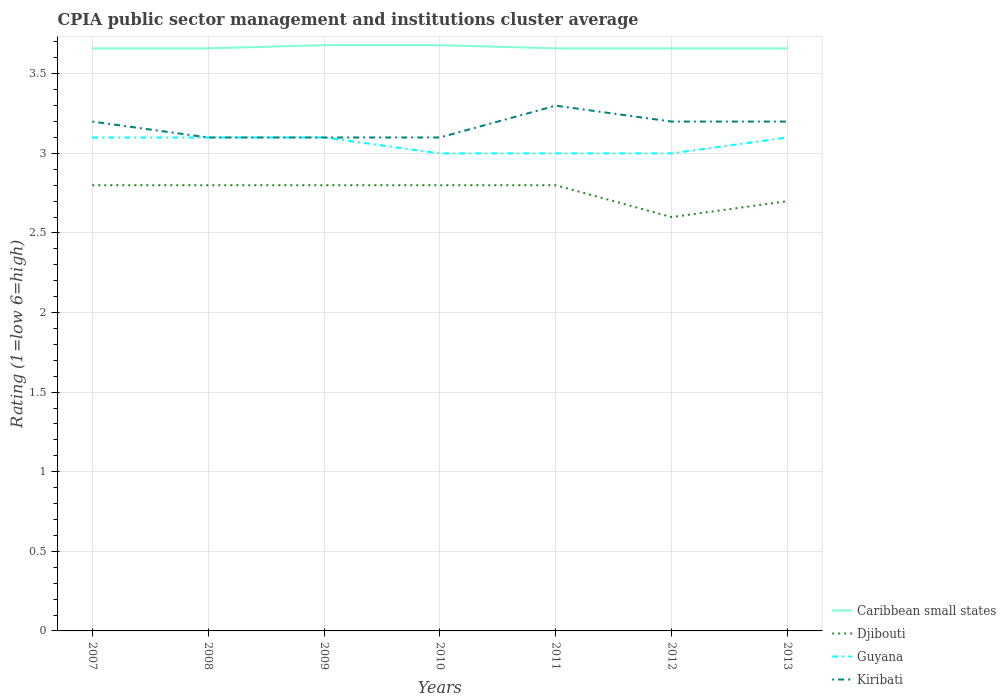How many different coloured lines are there?
Your response must be concise. 4. Does the line corresponding to Kiribati intersect with the line corresponding to Guyana?
Provide a short and direct response. Yes. Is the number of lines equal to the number of legend labels?
Ensure brevity in your answer.  Yes. Across all years, what is the maximum CPIA rating in Caribbean small states?
Provide a short and direct response. 3.66. In which year was the CPIA rating in Caribbean small states maximum?
Give a very brief answer. 2007. What is the difference between the highest and the second highest CPIA rating in Kiribati?
Your answer should be very brief. 0.2. Is the CPIA rating in Guyana strictly greater than the CPIA rating in Djibouti over the years?
Your answer should be compact. No. How many years are there in the graph?
Ensure brevity in your answer.  7. Does the graph contain grids?
Your answer should be very brief. Yes. Where does the legend appear in the graph?
Give a very brief answer. Bottom right. How are the legend labels stacked?
Give a very brief answer. Vertical. What is the title of the graph?
Your response must be concise. CPIA public sector management and institutions cluster average. Does "Tunisia" appear as one of the legend labels in the graph?
Ensure brevity in your answer.  No. What is the label or title of the X-axis?
Your answer should be compact. Years. What is the Rating (1=low 6=high) in Caribbean small states in 2007?
Provide a succinct answer. 3.66. What is the Rating (1=low 6=high) of Guyana in 2007?
Make the answer very short. 3.1. What is the Rating (1=low 6=high) of Kiribati in 2007?
Offer a very short reply. 3.2. What is the Rating (1=low 6=high) of Caribbean small states in 2008?
Ensure brevity in your answer.  3.66. What is the Rating (1=low 6=high) of Djibouti in 2008?
Your answer should be compact. 2.8. What is the Rating (1=low 6=high) of Caribbean small states in 2009?
Your answer should be compact. 3.68. What is the Rating (1=low 6=high) of Djibouti in 2009?
Your answer should be very brief. 2.8. What is the Rating (1=low 6=high) in Guyana in 2009?
Give a very brief answer. 3.1. What is the Rating (1=low 6=high) of Kiribati in 2009?
Give a very brief answer. 3.1. What is the Rating (1=low 6=high) of Caribbean small states in 2010?
Keep it short and to the point. 3.68. What is the Rating (1=low 6=high) in Kiribati in 2010?
Your response must be concise. 3.1. What is the Rating (1=low 6=high) of Caribbean small states in 2011?
Provide a short and direct response. 3.66. What is the Rating (1=low 6=high) of Guyana in 2011?
Your response must be concise. 3. What is the Rating (1=low 6=high) in Kiribati in 2011?
Your answer should be very brief. 3.3. What is the Rating (1=low 6=high) in Caribbean small states in 2012?
Make the answer very short. 3.66. What is the Rating (1=low 6=high) in Guyana in 2012?
Keep it short and to the point. 3. What is the Rating (1=low 6=high) in Kiribati in 2012?
Your response must be concise. 3.2. What is the Rating (1=low 6=high) of Caribbean small states in 2013?
Offer a very short reply. 3.66. What is the Rating (1=low 6=high) in Kiribati in 2013?
Your response must be concise. 3.2. Across all years, what is the maximum Rating (1=low 6=high) of Caribbean small states?
Your response must be concise. 3.68. Across all years, what is the maximum Rating (1=low 6=high) in Guyana?
Offer a terse response. 3.1. Across all years, what is the minimum Rating (1=low 6=high) in Caribbean small states?
Your answer should be very brief. 3.66. Across all years, what is the minimum Rating (1=low 6=high) in Djibouti?
Offer a very short reply. 2.6. Across all years, what is the minimum Rating (1=low 6=high) in Guyana?
Ensure brevity in your answer.  3. Across all years, what is the minimum Rating (1=low 6=high) of Kiribati?
Provide a short and direct response. 3.1. What is the total Rating (1=low 6=high) in Caribbean small states in the graph?
Make the answer very short. 25.66. What is the total Rating (1=low 6=high) in Djibouti in the graph?
Your response must be concise. 19.3. What is the total Rating (1=low 6=high) of Guyana in the graph?
Offer a very short reply. 21.4. What is the total Rating (1=low 6=high) of Kiribati in the graph?
Your response must be concise. 22.2. What is the difference between the Rating (1=low 6=high) of Djibouti in 2007 and that in 2008?
Provide a short and direct response. 0. What is the difference between the Rating (1=low 6=high) of Kiribati in 2007 and that in 2008?
Give a very brief answer. 0.1. What is the difference between the Rating (1=low 6=high) in Caribbean small states in 2007 and that in 2009?
Ensure brevity in your answer.  -0.02. What is the difference between the Rating (1=low 6=high) of Guyana in 2007 and that in 2009?
Offer a terse response. 0. What is the difference between the Rating (1=low 6=high) of Caribbean small states in 2007 and that in 2010?
Offer a terse response. -0.02. What is the difference between the Rating (1=low 6=high) of Caribbean small states in 2007 and that in 2012?
Your answer should be very brief. 0. What is the difference between the Rating (1=low 6=high) in Djibouti in 2007 and that in 2012?
Your answer should be very brief. 0.2. What is the difference between the Rating (1=low 6=high) of Guyana in 2007 and that in 2012?
Your answer should be compact. 0.1. What is the difference between the Rating (1=low 6=high) in Guyana in 2007 and that in 2013?
Your response must be concise. 0. What is the difference between the Rating (1=low 6=high) in Kiribati in 2007 and that in 2013?
Ensure brevity in your answer.  0. What is the difference between the Rating (1=low 6=high) of Caribbean small states in 2008 and that in 2009?
Offer a terse response. -0.02. What is the difference between the Rating (1=low 6=high) of Djibouti in 2008 and that in 2009?
Your answer should be compact. 0. What is the difference between the Rating (1=low 6=high) of Caribbean small states in 2008 and that in 2010?
Offer a very short reply. -0.02. What is the difference between the Rating (1=low 6=high) in Djibouti in 2008 and that in 2011?
Keep it short and to the point. 0. What is the difference between the Rating (1=low 6=high) of Guyana in 2008 and that in 2011?
Offer a terse response. 0.1. What is the difference between the Rating (1=low 6=high) of Caribbean small states in 2008 and that in 2012?
Your answer should be compact. 0. What is the difference between the Rating (1=low 6=high) of Djibouti in 2008 and that in 2012?
Keep it short and to the point. 0.2. What is the difference between the Rating (1=low 6=high) of Guyana in 2008 and that in 2012?
Your response must be concise. 0.1. What is the difference between the Rating (1=low 6=high) of Caribbean small states in 2008 and that in 2013?
Give a very brief answer. 0. What is the difference between the Rating (1=low 6=high) of Kiribati in 2008 and that in 2013?
Your answer should be very brief. -0.1. What is the difference between the Rating (1=low 6=high) in Caribbean small states in 2009 and that in 2010?
Your answer should be very brief. 0. What is the difference between the Rating (1=low 6=high) of Djibouti in 2009 and that in 2010?
Ensure brevity in your answer.  0. What is the difference between the Rating (1=low 6=high) in Djibouti in 2009 and that in 2011?
Your answer should be compact. 0. What is the difference between the Rating (1=low 6=high) in Guyana in 2009 and that in 2011?
Your answer should be very brief. 0.1. What is the difference between the Rating (1=low 6=high) of Kiribati in 2009 and that in 2011?
Provide a succinct answer. -0.2. What is the difference between the Rating (1=low 6=high) in Caribbean small states in 2009 and that in 2012?
Provide a short and direct response. 0.02. What is the difference between the Rating (1=low 6=high) of Djibouti in 2009 and that in 2012?
Your response must be concise. 0.2. What is the difference between the Rating (1=low 6=high) in Kiribati in 2009 and that in 2012?
Your answer should be compact. -0.1. What is the difference between the Rating (1=low 6=high) of Kiribati in 2009 and that in 2013?
Offer a terse response. -0.1. What is the difference between the Rating (1=low 6=high) in Caribbean small states in 2010 and that in 2011?
Make the answer very short. 0.02. What is the difference between the Rating (1=low 6=high) of Guyana in 2010 and that in 2011?
Make the answer very short. 0. What is the difference between the Rating (1=low 6=high) of Kiribati in 2010 and that in 2011?
Offer a very short reply. -0.2. What is the difference between the Rating (1=low 6=high) in Caribbean small states in 2010 and that in 2012?
Give a very brief answer. 0.02. What is the difference between the Rating (1=low 6=high) of Kiribati in 2010 and that in 2012?
Your response must be concise. -0.1. What is the difference between the Rating (1=low 6=high) in Caribbean small states in 2010 and that in 2013?
Ensure brevity in your answer.  0.02. What is the difference between the Rating (1=low 6=high) of Djibouti in 2010 and that in 2013?
Provide a succinct answer. 0.1. What is the difference between the Rating (1=low 6=high) in Guyana in 2010 and that in 2013?
Give a very brief answer. -0.1. What is the difference between the Rating (1=low 6=high) in Kiribati in 2010 and that in 2013?
Make the answer very short. -0.1. What is the difference between the Rating (1=low 6=high) of Guyana in 2011 and that in 2012?
Make the answer very short. 0. What is the difference between the Rating (1=low 6=high) in Djibouti in 2011 and that in 2013?
Your response must be concise. 0.1. What is the difference between the Rating (1=low 6=high) in Guyana in 2011 and that in 2013?
Offer a terse response. -0.1. What is the difference between the Rating (1=low 6=high) of Caribbean small states in 2012 and that in 2013?
Make the answer very short. 0. What is the difference between the Rating (1=low 6=high) of Djibouti in 2012 and that in 2013?
Provide a short and direct response. -0.1. What is the difference between the Rating (1=low 6=high) of Guyana in 2012 and that in 2013?
Provide a short and direct response. -0.1. What is the difference between the Rating (1=low 6=high) in Kiribati in 2012 and that in 2013?
Your response must be concise. 0. What is the difference between the Rating (1=low 6=high) in Caribbean small states in 2007 and the Rating (1=low 6=high) in Djibouti in 2008?
Ensure brevity in your answer.  0.86. What is the difference between the Rating (1=low 6=high) in Caribbean small states in 2007 and the Rating (1=low 6=high) in Guyana in 2008?
Provide a succinct answer. 0.56. What is the difference between the Rating (1=low 6=high) of Caribbean small states in 2007 and the Rating (1=low 6=high) of Kiribati in 2008?
Offer a terse response. 0.56. What is the difference between the Rating (1=low 6=high) of Caribbean small states in 2007 and the Rating (1=low 6=high) of Djibouti in 2009?
Your answer should be compact. 0.86. What is the difference between the Rating (1=low 6=high) in Caribbean small states in 2007 and the Rating (1=low 6=high) in Guyana in 2009?
Keep it short and to the point. 0.56. What is the difference between the Rating (1=low 6=high) of Caribbean small states in 2007 and the Rating (1=low 6=high) of Kiribati in 2009?
Make the answer very short. 0.56. What is the difference between the Rating (1=low 6=high) of Djibouti in 2007 and the Rating (1=low 6=high) of Kiribati in 2009?
Make the answer very short. -0.3. What is the difference between the Rating (1=low 6=high) in Caribbean small states in 2007 and the Rating (1=low 6=high) in Djibouti in 2010?
Ensure brevity in your answer.  0.86. What is the difference between the Rating (1=low 6=high) of Caribbean small states in 2007 and the Rating (1=low 6=high) of Guyana in 2010?
Make the answer very short. 0.66. What is the difference between the Rating (1=low 6=high) in Caribbean small states in 2007 and the Rating (1=low 6=high) in Kiribati in 2010?
Offer a terse response. 0.56. What is the difference between the Rating (1=low 6=high) of Djibouti in 2007 and the Rating (1=low 6=high) of Guyana in 2010?
Your response must be concise. -0.2. What is the difference between the Rating (1=low 6=high) in Caribbean small states in 2007 and the Rating (1=low 6=high) in Djibouti in 2011?
Your response must be concise. 0.86. What is the difference between the Rating (1=low 6=high) in Caribbean small states in 2007 and the Rating (1=low 6=high) in Guyana in 2011?
Provide a succinct answer. 0.66. What is the difference between the Rating (1=low 6=high) in Caribbean small states in 2007 and the Rating (1=low 6=high) in Kiribati in 2011?
Make the answer very short. 0.36. What is the difference between the Rating (1=low 6=high) of Djibouti in 2007 and the Rating (1=low 6=high) of Guyana in 2011?
Offer a very short reply. -0.2. What is the difference between the Rating (1=low 6=high) in Guyana in 2007 and the Rating (1=low 6=high) in Kiribati in 2011?
Provide a short and direct response. -0.2. What is the difference between the Rating (1=low 6=high) in Caribbean small states in 2007 and the Rating (1=low 6=high) in Djibouti in 2012?
Provide a short and direct response. 1.06. What is the difference between the Rating (1=low 6=high) in Caribbean small states in 2007 and the Rating (1=low 6=high) in Guyana in 2012?
Provide a short and direct response. 0.66. What is the difference between the Rating (1=low 6=high) in Caribbean small states in 2007 and the Rating (1=low 6=high) in Kiribati in 2012?
Offer a very short reply. 0.46. What is the difference between the Rating (1=low 6=high) in Djibouti in 2007 and the Rating (1=low 6=high) in Guyana in 2012?
Your answer should be compact. -0.2. What is the difference between the Rating (1=low 6=high) of Djibouti in 2007 and the Rating (1=low 6=high) of Kiribati in 2012?
Your response must be concise. -0.4. What is the difference between the Rating (1=low 6=high) in Caribbean small states in 2007 and the Rating (1=low 6=high) in Djibouti in 2013?
Your answer should be compact. 0.96. What is the difference between the Rating (1=low 6=high) in Caribbean small states in 2007 and the Rating (1=low 6=high) in Guyana in 2013?
Offer a very short reply. 0.56. What is the difference between the Rating (1=low 6=high) in Caribbean small states in 2007 and the Rating (1=low 6=high) in Kiribati in 2013?
Your response must be concise. 0.46. What is the difference between the Rating (1=low 6=high) in Djibouti in 2007 and the Rating (1=low 6=high) in Kiribati in 2013?
Offer a terse response. -0.4. What is the difference between the Rating (1=low 6=high) in Guyana in 2007 and the Rating (1=low 6=high) in Kiribati in 2013?
Offer a very short reply. -0.1. What is the difference between the Rating (1=low 6=high) of Caribbean small states in 2008 and the Rating (1=low 6=high) of Djibouti in 2009?
Ensure brevity in your answer.  0.86. What is the difference between the Rating (1=low 6=high) of Caribbean small states in 2008 and the Rating (1=low 6=high) of Guyana in 2009?
Offer a very short reply. 0.56. What is the difference between the Rating (1=low 6=high) of Caribbean small states in 2008 and the Rating (1=low 6=high) of Kiribati in 2009?
Your response must be concise. 0.56. What is the difference between the Rating (1=low 6=high) of Guyana in 2008 and the Rating (1=low 6=high) of Kiribati in 2009?
Give a very brief answer. 0. What is the difference between the Rating (1=low 6=high) of Caribbean small states in 2008 and the Rating (1=low 6=high) of Djibouti in 2010?
Give a very brief answer. 0.86. What is the difference between the Rating (1=low 6=high) in Caribbean small states in 2008 and the Rating (1=low 6=high) in Guyana in 2010?
Make the answer very short. 0.66. What is the difference between the Rating (1=low 6=high) of Caribbean small states in 2008 and the Rating (1=low 6=high) of Kiribati in 2010?
Provide a short and direct response. 0.56. What is the difference between the Rating (1=low 6=high) of Guyana in 2008 and the Rating (1=low 6=high) of Kiribati in 2010?
Make the answer very short. 0. What is the difference between the Rating (1=low 6=high) in Caribbean small states in 2008 and the Rating (1=low 6=high) in Djibouti in 2011?
Your response must be concise. 0.86. What is the difference between the Rating (1=low 6=high) of Caribbean small states in 2008 and the Rating (1=low 6=high) of Guyana in 2011?
Provide a succinct answer. 0.66. What is the difference between the Rating (1=low 6=high) of Caribbean small states in 2008 and the Rating (1=low 6=high) of Kiribati in 2011?
Your answer should be compact. 0.36. What is the difference between the Rating (1=low 6=high) of Djibouti in 2008 and the Rating (1=low 6=high) of Kiribati in 2011?
Your response must be concise. -0.5. What is the difference between the Rating (1=low 6=high) in Guyana in 2008 and the Rating (1=low 6=high) in Kiribati in 2011?
Your answer should be compact. -0.2. What is the difference between the Rating (1=low 6=high) of Caribbean small states in 2008 and the Rating (1=low 6=high) of Djibouti in 2012?
Make the answer very short. 1.06. What is the difference between the Rating (1=low 6=high) of Caribbean small states in 2008 and the Rating (1=low 6=high) of Guyana in 2012?
Provide a short and direct response. 0.66. What is the difference between the Rating (1=low 6=high) of Caribbean small states in 2008 and the Rating (1=low 6=high) of Kiribati in 2012?
Make the answer very short. 0.46. What is the difference between the Rating (1=low 6=high) in Djibouti in 2008 and the Rating (1=low 6=high) in Kiribati in 2012?
Provide a succinct answer. -0.4. What is the difference between the Rating (1=low 6=high) in Caribbean small states in 2008 and the Rating (1=low 6=high) in Djibouti in 2013?
Give a very brief answer. 0.96. What is the difference between the Rating (1=low 6=high) in Caribbean small states in 2008 and the Rating (1=low 6=high) in Guyana in 2013?
Provide a short and direct response. 0.56. What is the difference between the Rating (1=low 6=high) of Caribbean small states in 2008 and the Rating (1=low 6=high) of Kiribati in 2013?
Provide a succinct answer. 0.46. What is the difference between the Rating (1=low 6=high) of Djibouti in 2008 and the Rating (1=low 6=high) of Kiribati in 2013?
Provide a short and direct response. -0.4. What is the difference between the Rating (1=low 6=high) in Caribbean small states in 2009 and the Rating (1=low 6=high) in Djibouti in 2010?
Your response must be concise. 0.88. What is the difference between the Rating (1=low 6=high) of Caribbean small states in 2009 and the Rating (1=low 6=high) of Guyana in 2010?
Your answer should be very brief. 0.68. What is the difference between the Rating (1=low 6=high) of Caribbean small states in 2009 and the Rating (1=low 6=high) of Kiribati in 2010?
Keep it short and to the point. 0.58. What is the difference between the Rating (1=low 6=high) of Djibouti in 2009 and the Rating (1=low 6=high) of Guyana in 2010?
Offer a terse response. -0.2. What is the difference between the Rating (1=low 6=high) of Caribbean small states in 2009 and the Rating (1=low 6=high) of Guyana in 2011?
Offer a terse response. 0.68. What is the difference between the Rating (1=low 6=high) of Caribbean small states in 2009 and the Rating (1=low 6=high) of Kiribati in 2011?
Offer a very short reply. 0.38. What is the difference between the Rating (1=low 6=high) of Djibouti in 2009 and the Rating (1=low 6=high) of Kiribati in 2011?
Your response must be concise. -0.5. What is the difference between the Rating (1=low 6=high) of Guyana in 2009 and the Rating (1=low 6=high) of Kiribati in 2011?
Offer a terse response. -0.2. What is the difference between the Rating (1=low 6=high) of Caribbean small states in 2009 and the Rating (1=low 6=high) of Djibouti in 2012?
Your answer should be very brief. 1.08. What is the difference between the Rating (1=low 6=high) in Caribbean small states in 2009 and the Rating (1=low 6=high) in Guyana in 2012?
Offer a very short reply. 0.68. What is the difference between the Rating (1=low 6=high) of Caribbean small states in 2009 and the Rating (1=low 6=high) of Kiribati in 2012?
Provide a short and direct response. 0.48. What is the difference between the Rating (1=low 6=high) in Djibouti in 2009 and the Rating (1=low 6=high) in Guyana in 2012?
Give a very brief answer. -0.2. What is the difference between the Rating (1=low 6=high) in Caribbean small states in 2009 and the Rating (1=low 6=high) in Guyana in 2013?
Make the answer very short. 0.58. What is the difference between the Rating (1=low 6=high) in Caribbean small states in 2009 and the Rating (1=low 6=high) in Kiribati in 2013?
Offer a terse response. 0.48. What is the difference between the Rating (1=low 6=high) of Djibouti in 2009 and the Rating (1=low 6=high) of Guyana in 2013?
Ensure brevity in your answer.  -0.3. What is the difference between the Rating (1=low 6=high) of Guyana in 2009 and the Rating (1=low 6=high) of Kiribati in 2013?
Offer a terse response. -0.1. What is the difference between the Rating (1=low 6=high) in Caribbean small states in 2010 and the Rating (1=low 6=high) in Djibouti in 2011?
Your answer should be compact. 0.88. What is the difference between the Rating (1=low 6=high) of Caribbean small states in 2010 and the Rating (1=low 6=high) of Guyana in 2011?
Make the answer very short. 0.68. What is the difference between the Rating (1=low 6=high) in Caribbean small states in 2010 and the Rating (1=low 6=high) in Kiribati in 2011?
Your answer should be very brief. 0.38. What is the difference between the Rating (1=low 6=high) in Caribbean small states in 2010 and the Rating (1=low 6=high) in Djibouti in 2012?
Make the answer very short. 1.08. What is the difference between the Rating (1=low 6=high) of Caribbean small states in 2010 and the Rating (1=low 6=high) of Guyana in 2012?
Offer a very short reply. 0.68. What is the difference between the Rating (1=low 6=high) of Caribbean small states in 2010 and the Rating (1=low 6=high) of Kiribati in 2012?
Offer a terse response. 0.48. What is the difference between the Rating (1=low 6=high) of Djibouti in 2010 and the Rating (1=low 6=high) of Guyana in 2012?
Your answer should be compact. -0.2. What is the difference between the Rating (1=low 6=high) of Djibouti in 2010 and the Rating (1=low 6=high) of Kiribati in 2012?
Your answer should be very brief. -0.4. What is the difference between the Rating (1=low 6=high) of Guyana in 2010 and the Rating (1=low 6=high) of Kiribati in 2012?
Your response must be concise. -0.2. What is the difference between the Rating (1=low 6=high) of Caribbean small states in 2010 and the Rating (1=low 6=high) of Djibouti in 2013?
Keep it short and to the point. 0.98. What is the difference between the Rating (1=low 6=high) of Caribbean small states in 2010 and the Rating (1=low 6=high) of Guyana in 2013?
Ensure brevity in your answer.  0.58. What is the difference between the Rating (1=low 6=high) of Caribbean small states in 2010 and the Rating (1=low 6=high) of Kiribati in 2013?
Your answer should be compact. 0.48. What is the difference between the Rating (1=low 6=high) of Djibouti in 2010 and the Rating (1=low 6=high) of Guyana in 2013?
Your answer should be very brief. -0.3. What is the difference between the Rating (1=low 6=high) in Caribbean small states in 2011 and the Rating (1=low 6=high) in Djibouti in 2012?
Give a very brief answer. 1.06. What is the difference between the Rating (1=low 6=high) of Caribbean small states in 2011 and the Rating (1=low 6=high) of Guyana in 2012?
Give a very brief answer. 0.66. What is the difference between the Rating (1=low 6=high) in Caribbean small states in 2011 and the Rating (1=low 6=high) in Kiribati in 2012?
Your answer should be compact. 0.46. What is the difference between the Rating (1=low 6=high) of Djibouti in 2011 and the Rating (1=low 6=high) of Kiribati in 2012?
Offer a terse response. -0.4. What is the difference between the Rating (1=low 6=high) of Guyana in 2011 and the Rating (1=low 6=high) of Kiribati in 2012?
Keep it short and to the point. -0.2. What is the difference between the Rating (1=low 6=high) in Caribbean small states in 2011 and the Rating (1=low 6=high) in Djibouti in 2013?
Keep it short and to the point. 0.96. What is the difference between the Rating (1=low 6=high) of Caribbean small states in 2011 and the Rating (1=low 6=high) of Guyana in 2013?
Give a very brief answer. 0.56. What is the difference between the Rating (1=low 6=high) in Caribbean small states in 2011 and the Rating (1=low 6=high) in Kiribati in 2013?
Offer a very short reply. 0.46. What is the difference between the Rating (1=low 6=high) of Guyana in 2011 and the Rating (1=low 6=high) of Kiribati in 2013?
Keep it short and to the point. -0.2. What is the difference between the Rating (1=low 6=high) in Caribbean small states in 2012 and the Rating (1=low 6=high) in Djibouti in 2013?
Make the answer very short. 0.96. What is the difference between the Rating (1=low 6=high) in Caribbean small states in 2012 and the Rating (1=low 6=high) in Guyana in 2013?
Provide a short and direct response. 0.56. What is the difference between the Rating (1=low 6=high) in Caribbean small states in 2012 and the Rating (1=low 6=high) in Kiribati in 2013?
Your response must be concise. 0.46. What is the difference between the Rating (1=low 6=high) of Djibouti in 2012 and the Rating (1=low 6=high) of Kiribati in 2013?
Provide a succinct answer. -0.6. What is the average Rating (1=low 6=high) of Caribbean small states per year?
Your response must be concise. 3.67. What is the average Rating (1=low 6=high) in Djibouti per year?
Offer a terse response. 2.76. What is the average Rating (1=low 6=high) in Guyana per year?
Your answer should be very brief. 3.06. What is the average Rating (1=low 6=high) in Kiribati per year?
Provide a short and direct response. 3.17. In the year 2007, what is the difference between the Rating (1=low 6=high) of Caribbean small states and Rating (1=low 6=high) of Djibouti?
Your answer should be compact. 0.86. In the year 2007, what is the difference between the Rating (1=low 6=high) in Caribbean small states and Rating (1=low 6=high) in Guyana?
Your response must be concise. 0.56. In the year 2007, what is the difference between the Rating (1=low 6=high) in Caribbean small states and Rating (1=low 6=high) in Kiribati?
Give a very brief answer. 0.46. In the year 2007, what is the difference between the Rating (1=low 6=high) of Guyana and Rating (1=low 6=high) of Kiribati?
Offer a terse response. -0.1. In the year 2008, what is the difference between the Rating (1=low 6=high) in Caribbean small states and Rating (1=low 6=high) in Djibouti?
Your response must be concise. 0.86. In the year 2008, what is the difference between the Rating (1=low 6=high) in Caribbean small states and Rating (1=low 6=high) in Guyana?
Provide a short and direct response. 0.56. In the year 2008, what is the difference between the Rating (1=low 6=high) in Caribbean small states and Rating (1=low 6=high) in Kiribati?
Your answer should be compact. 0.56. In the year 2008, what is the difference between the Rating (1=low 6=high) in Djibouti and Rating (1=low 6=high) in Guyana?
Offer a very short reply. -0.3. In the year 2008, what is the difference between the Rating (1=low 6=high) in Guyana and Rating (1=low 6=high) in Kiribati?
Make the answer very short. 0. In the year 2009, what is the difference between the Rating (1=low 6=high) in Caribbean small states and Rating (1=low 6=high) in Djibouti?
Provide a succinct answer. 0.88. In the year 2009, what is the difference between the Rating (1=low 6=high) in Caribbean small states and Rating (1=low 6=high) in Guyana?
Offer a very short reply. 0.58. In the year 2009, what is the difference between the Rating (1=low 6=high) of Caribbean small states and Rating (1=low 6=high) of Kiribati?
Give a very brief answer. 0.58. In the year 2009, what is the difference between the Rating (1=low 6=high) in Djibouti and Rating (1=low 6=high) in Guyana?
Give a very brief answer. -0.3. In the year 2009, what is the difference between the Rating (1=low 6=high) in Guyana and Rating (1=low 6=high) in Kiribati?
Offer a very short reply. 0. In the year 2010, what is the difference between the Rating (1=low 6=high) in Caribbean small states and Rating (1=low 6=high) in Djibouti?
Provide a succinct answer. 0.88. In the year 2010, what is the difference between the Rating (1=low 6=high) in Caribbean small states and Rating (1=low 6=high) in Guyana?
Provide a succinct answer. 0.68. In the year 2010, what is the difference between the Rating (1=low 6=high) in Caribbean small states and Rating (1=low 6=high) in Kiribati?
Provide a succinct answer. 0.58. In the year 2010, what is the difference between the Rating (1=low 6=high) of Guyana and Rating (1=low 6=high) of Kiribati?
Provide a succinct answer. -0.1. In the year 2011, what is the difference between the Rating (1=low 6=high) in Caribbean small states and Rating (1=low 6=high) in Djibouti?
Ensure brevity in your answer.  0.86. In the year 2011, what is the difference between the Rating (1=low 6=high) of Caribbean small states and Rating (1=low 6=high) of Guyana?
Provide a succinct answer. 0.66. In the year 2011, what is the difference between the Rating (1=low 6=high) in Caribbean small states and Rating (1=low 6=high) in Kiribati?
Ensure brevity in your answer.  0.36. In the year 2011, what is the difference between the Rating (1=low 6=high) in Djibouti and Rating (1=low 6=high) in Guyana?
Your answer should be very brief. -0.2. In the year 2011, what is the difference between the Rating (1=low 6=high) of Djibouti and Rating (1=low 6=high) of Kiribati?
Provide a short and direct response. -0.5. In the year 2012, what is the difference between the Rating (1=low 6=high) in Caribbean small states and Rating (1=low 6=high) in Djibouti?
Offer a terse response. 1.06. In the year 2012, what is the difference between the Rating (1=low 6=high) in Caribbean small states and Rating (1=low 6=high) in Guyana?
Offer a very short reply. 0.66. In the year 2012, what is the difference between the Rating (1=low 6=high) of Caribbean small states and Rating (1=low 6=high) of Kiribati?
Provide a succinct answer. 0.46. In the year 2013, what is the difference between the Rating (1=low 6=high) of Caribbean small states and Rating (1=low 6=high) of Djibouti?
Keep it short and to the point. 0.96. In the year 2013, what is the difference between the Rating (1=low 6=high) in Caribbean small states and Rating (1=low 6=high) in Guyana?
Your answer should be compact. 0.56. In the year 2013, what is the difference between the Rating (1=low 6=high) of Caribbean small states and Rating (1=low 6=high) of Kiribati?
Ensure brevity in your answer.  0.46. In the year 2013, what is the difference between the Rating (1=low 6=high) in Djibouti and Rating (1=low 6=high) in Guyana?
Offer a very short reply. -0.4. In the year 2013, what is the difference between the Rating (1=low 6=high) of Guyana and Rating (1=low 6=high) of Kiribati?
Give a very brief answer. -0.1. What is the ratio of the Rating (1=low 6=high) in Caribbean small states in 2007 to that in 2008?
Offer a very short reply. 1. What is the ratio of the Rating (1=low 6=high) in Kiribati in 2007 to that in 2008?
Ensure brevity in your answer.  1.03. What is the ratio of the Rating (1=low 6=high) in Guyana in 2007 to that in 2009?
Make the answer very short. 1. What is the ratio of the Rating (1=low 6=high) of Kiribati in 2007 to that in 2009?
Your answer should be very brief. 1.03. What is the ratio of the Rating (1=low 6=high) of Caribbean small states in 2007 to that in 2010?
Your answer should be compact. 0.99. What is the ratio of the Rating (1=low 6=high) in Kiribati in 2007 to that in 2010?
Your answer should be very brief. 1.03. What is the ratio of the Rating (1=low 6=high) in Djibouti in 2007 to that in 2011?
Provide a short and direct response. 1. What is the ratio of the Rating (1=low 6=high) in Kiribati in 2007 to that in 2011?
Offer a very short reply. 0.97. What is the ratio of the Rating (1=low 6=high) of Djibouti in 2007 to that in 2012?
Your response must be concise. 1.08. What is the ratio of the Rating (1=low 6=high) of Guyana in 2007 to that in 2012?
Provide a succinct answer. 1.03. What is the ratio of the Rating (1=low 6=high) in Caribbean small states in 2007 to that in 2013?
Your answer should be very brief. 1. What is the ratio of the Rating (1=low 6=high) in Caribbean small states in 2008 to that in 2009?
Offer a terse response. 0.99. What is the ratio of the Rating (1=low 6=high) of Guyana in 2008 to that in 2009?
Give a very brief answer. 1. What is the ratio of the Rating (1=low 6=high) in Caribbean small states in 2008 to that in 2010?
Your response must be concise. 0.99. What is the ratio of the Rating (1=low 6=high) of Guyana in 2008 to that in 2010?
Ensure brevity in your answer.  1.03. What is the ratio of the Rating (1=low 6=high) in Kiribati in 2008 to that in 2010?
Your response must be concise. 1. What is the ratio of the Rating (1=low 6=high) in Guyana in 2008 to that in 2011?
Keep it short and to the point. 1.03. What is the ratio of the Rating (1=low 6=high) in Kiribati in 2008 to that in 2011?
Ensure brevity in your answer.  0.94. What is the ratio of the Rating (1=low 6=high) in Guyana in 2008 to that in 2012?
Give a very brief answer. 1.03. What is the ratio of the Rating (1=low 6=high) of Kiribati in 2008 to that in 2012?
Make the answer very short. 0.97. What is the ratio of the Rating (1=low 6=high) in Djibouti in 2008 to that in 2013?
Provide a short and direct response. 1.04. What is the ratio of the Rating (1=low 6=high) of Guyana in 2008 to that in 2013?
Your response must be concise. 1. What is the ratio of the Rating (1=low 6=high) of Kiribati in 2008 to that in 2013?
Your answer should be compact. 0.97. What is the ratio of the Rating (1=low 6=high) of Djibouti in 2009 to that in 2010?
Your answer should be very brief. 1. What is the ratio of the Rating (1=low 6=high) of Guyana in 2009 to that in 2010?
Your answer should be very brief. 1.03. What is the ratio of the Rating (1=low 6=high) in Kiribati in 2009 to that in 2010?
Provide a succinct answer. 1. What is the ratio of the Rating (1=low 6=high) of Guyana in 2009 to that in 2011?
Make the answer very short. 1.03. What is the ratio of the Rating (1=low 6=high) of Kiribati in 2009 to that in 2011?
Give a very brief answer. 0.94. What is the ratio of the Rating (1=low 6=high) in Caribbean small states in 2009 to that in 2012?
Provide a short and direct response. 1.01. What is the ratio of the Rating (1=low 6=high) in Guyana in 2009 to that in 2012?
Give a very brief answer. 1.03. What is the ratio of the Rating (1=low 6=high) in Kiribati in 2009 to that in 2012?
Your answer should be compact. 0.97. What is the ratio of the Rating (1=low 6=high) in Guyana in 2009 to that in 2013?
Make the answer very short. 1. What is the ratio of the Rating (1=low 6=high) in Kiribati in 2009 to that in 2013?
Provide a succinct answer. 0.97. What is the ratio of the Rating (1=low 6=high) of Caribbean small states in 2010 to that in 2011?
Offer a terse response. 1.01. What is the ratio of the Rating (1=low 6=high) of Kiribati in 2010 to that in 2011?
Give a very brief answer. 0.94. What is the ratio of the Rating (1=low 6=high) in Djibouti in 2010 to that in 2012?
Offer a terse response. 1.08. What is the ratio of the Rating (1=low 6=high) in Kiribati in 2010 to that in 2012?
Provide a succinct answer. 0.97. What is the ratio of the Rating (1=low 6=high) in Caribbean small states in 2010 to that in 2013?
Provide a succinct answer. 1.01. What is the ratio of the Rating (1=low 6=high) in Djibouti in 2010 to that in 2013?
Offer a terse response. 1.04. What is the ratio of the Rating (1=low 6=high) in Kiribati in 2010 to that in 2013?
Your answer should be compact. 0.97. What is the ratio of the Rating (1=low 6=high) of Caribbean small states in 2011 to that in 2012?
Provide a succinct answer. 1. What is the ratio of the Rating (1=low 6=high) in Djibouti in 2011 to that in 2012?
Offer a very short reply. 1.08. What is the ratio of the Rating (1=low 6=high) in Guyana in 2011 to that in 2012?
Offer a very short reply. 1. What is the ratio of the Rating (1=low 6=high) of Kiribati in 2011 to that in 2012?
Your response must be concise. 1.03. What is the ratio of the Rating (1=low 6=high) of Kiribati in 2011 to that in 2013?
Provide a short and direct response. 1.03. What is the ratio of the Rating (1=low 6=high) of Kiribati in 2012 to that in 2013?
Keep it short and to the point. 1. What is the difference between the highest and the second highest Rating (1=low 6=high) of Caribbean small states?
Offer a terse response. 0. What is the difference between the highest and the second highest Rating (1=low 6=high) of Guyana?
Keep it short and to the point. 0. What is the difference between the highest and the lowest Rating (1=low 6=high) of Djibouti?
Your answer should be very brief. 0.2. What is the difference between the highest and the lowest Rating (1=low 6=high) of Guyana?
Make the answer very short. 0.1. 